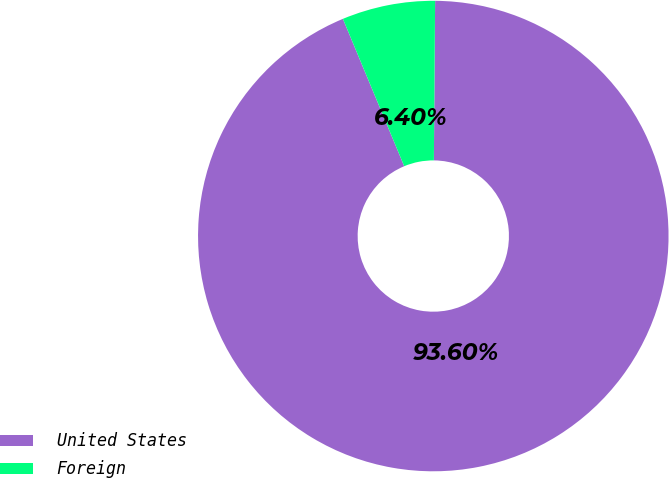Convert chart to OTSL. <chart><loc_0><loc_0><loc_500><loc_500><pie_chart><fcel>United States<fcel>Foreign<nl><fcel>93.6%<fcel>6.4%<nl></chart> 